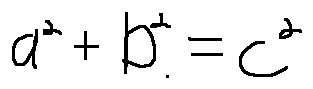<formula> <loc_0><loc_0><loc_500><loc_500>a ^ { 2 } + b ^ { 2 } = c ^ { 2 }</formula> 